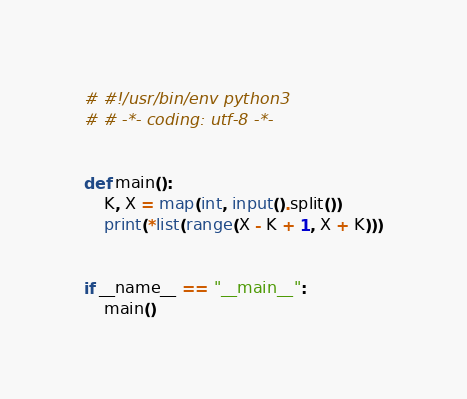<code> <loc_0><loc_0><loc_500><loc_500><_Python_># #!/usr/bin/env python3
# # -*- coding: utf-8 -*-


def main():
    K, X = map(int, input().split())
    print(*list(range(X - K + 1, X + K)))


if __name__ == "__main__":
    main()
</code> 